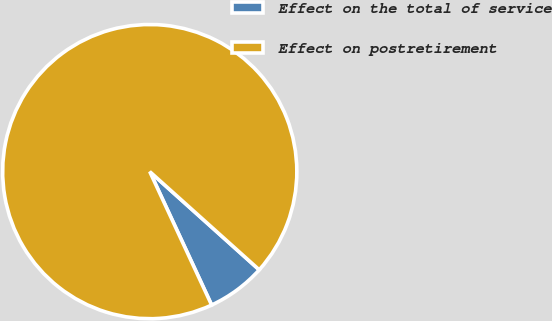Convert chart to OTSL. <chart><loc_0><loc_0><loc_500><loc_500><pie_chart><fcel>Effect on the total of service<fcel>Effect on postretirement<nl><fcel>6.45%<fcel>93.55%<nl></chart> 